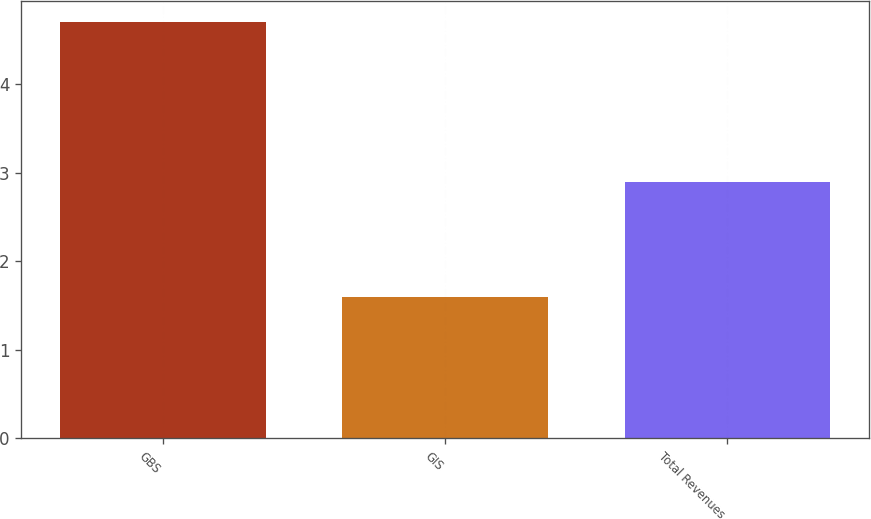<chart> <loc_0><loc_0><loc_500><loc_500><bar_chart><fcel>GBS<fcel>GIS<fcel>Total Revenues<nl><fcel>4.7<fcel>1.6<fcel>2.9<nl></chart> 